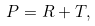Convert formula to latex. <formula><loc_0><loc_0><loc_500><loc_500>P = R + T ,</formula> 